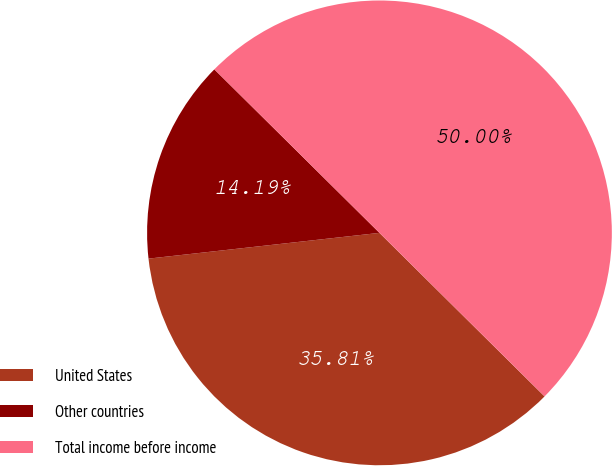<chart> <loc_0><loc_0><loc_500><loc_500><pie_chart><fcel>United States<fcel>Other countries<fcel>Total income before income<nl><fcel>35.81%<fcel>14.19%<fcel>50.0%<nl></chart> 